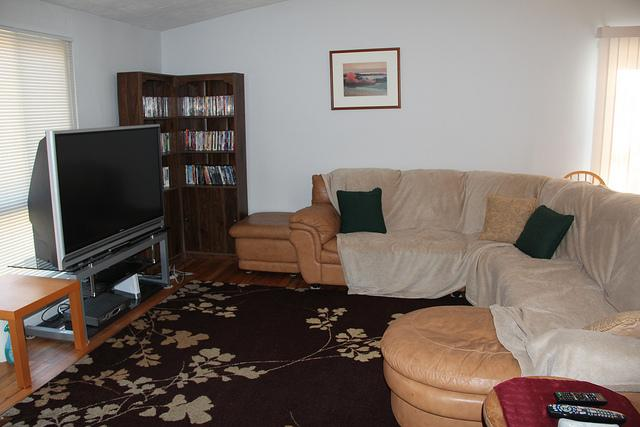How many portraits are hung on the white wall? Please explain your reasoning. one. The portrait above the sofa is by itself. 